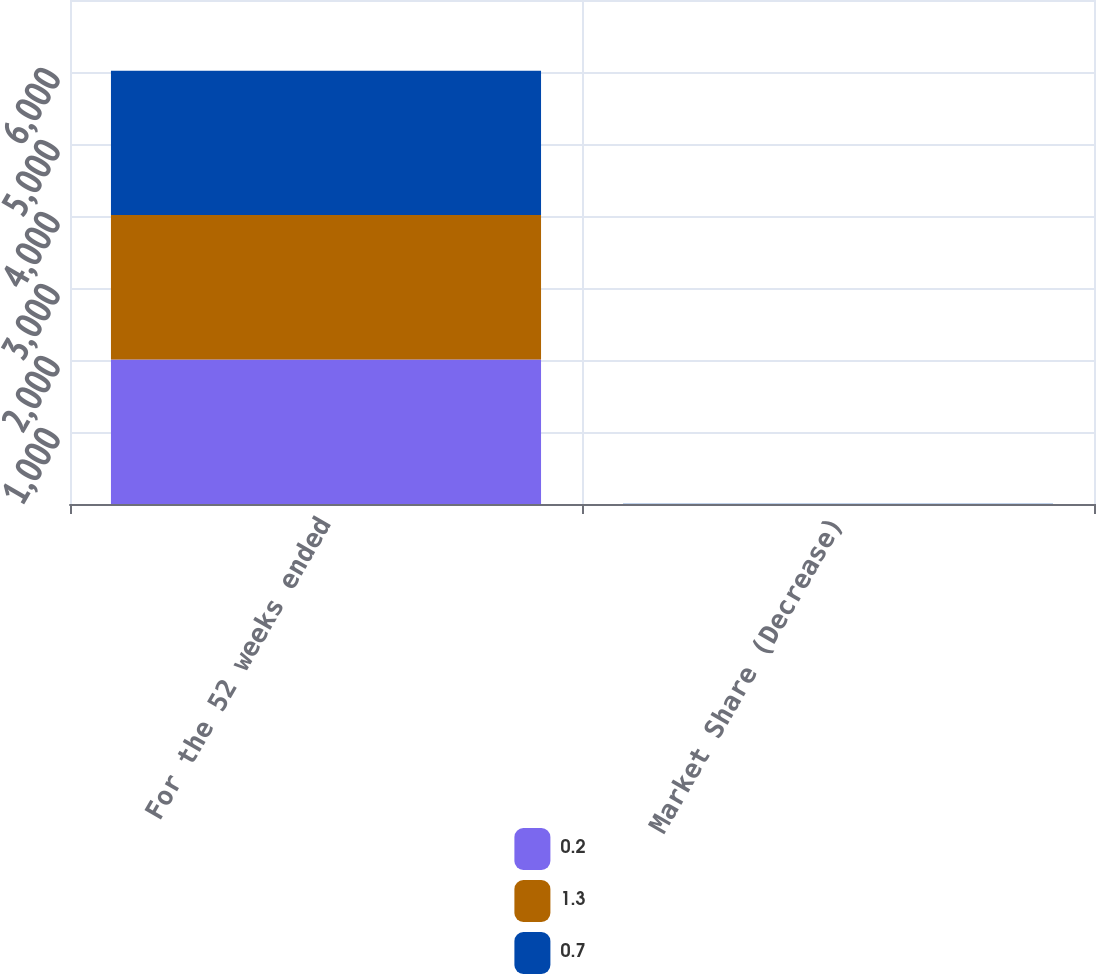<chart> <loc_0><loc_0><loc_500><loc_500><stacked_bar_chart><ecel><fcel>For the 52 weeks ended<fcel>Market Share (Decrease)<nl><fcel>0.2<fcel>2007<fcel>1.3<nl><fcel>1.3<fcel>2006<fcel>0.2<nl><fcel>0.7<fcel>2005<fcel>0.7<nl></chart> 